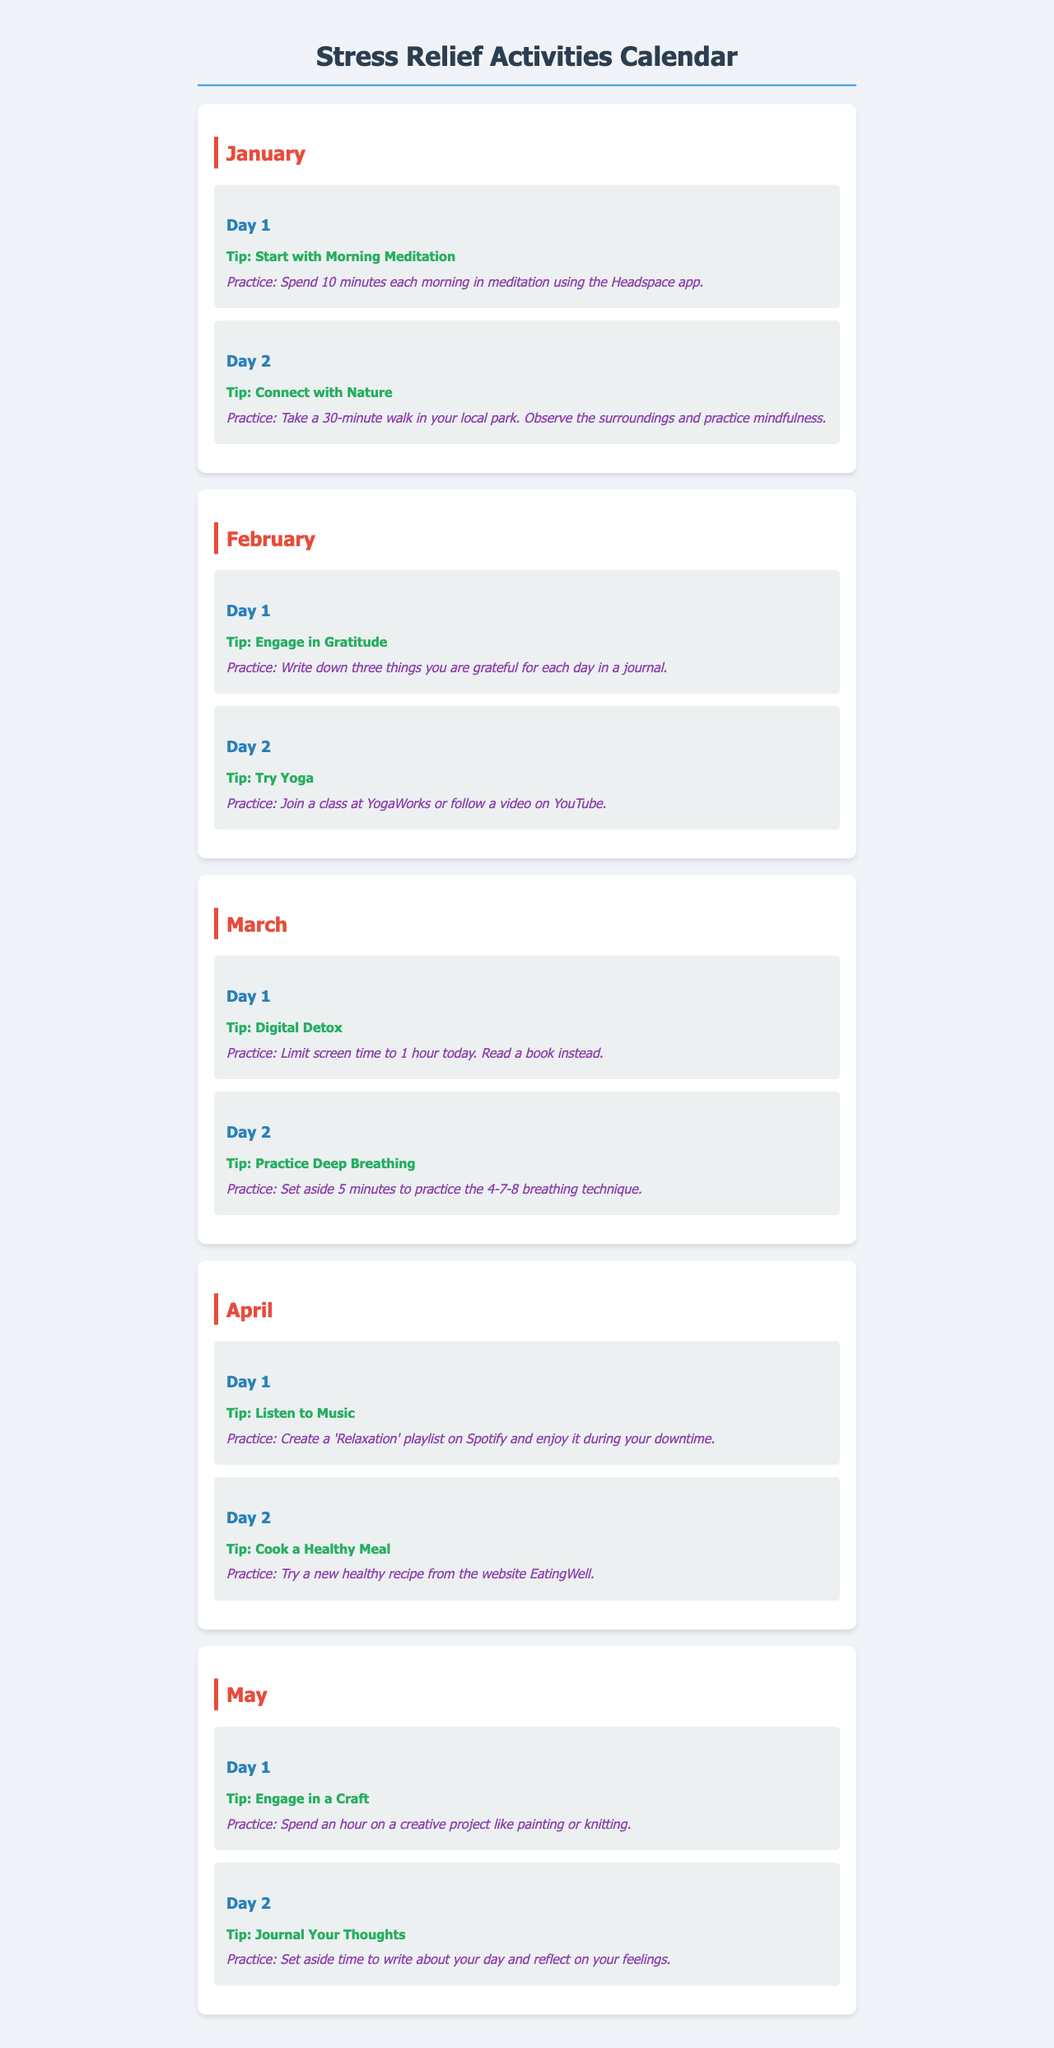What is the title of the document? The title is stated in the header of the document.
Answer: Stress Relief Activities Calendar How many days are suggested for stress relief activities in January? Each month has a set of days with activities listed; January has two days mentioned.
Answer: 2 What is the first tip for Day 1 in January? The first tip is provided for each day; in January, Day 1’s tip is about meditation.
Answer: Start with Morning Meditation What practice is suggested for Day 2 of March? Each day has a specified practice; for March Day 2, it includes a specific breathing technique.
Answer: Set aside 5 minutes to practice the 4-7-8 breathing technique Which month includes the suggestion to engage in a craft? Each month has unique activities; this suggestion specifically appears in May.
Answer: May What is the suggested activity for Day 1 of April? The document mentions a specific activity for each day; for Day 1 of April, it is related to music.
Answer: Listen to Music How many total practice suggestions are provided for February? Two days of practices are listed for each month; February has two practices.
Answer: 2 What is the benefit of writing down three things you are grateful for? This tip is linked to gratitude and mental well-being; it's mentioned in the suggestion itself.
Answer: Engage in Gratitude What color is used for the day headers? The style of the day headers can be found in the document’s CSS; they use a specific color for emphasis.
Answer: Blue 